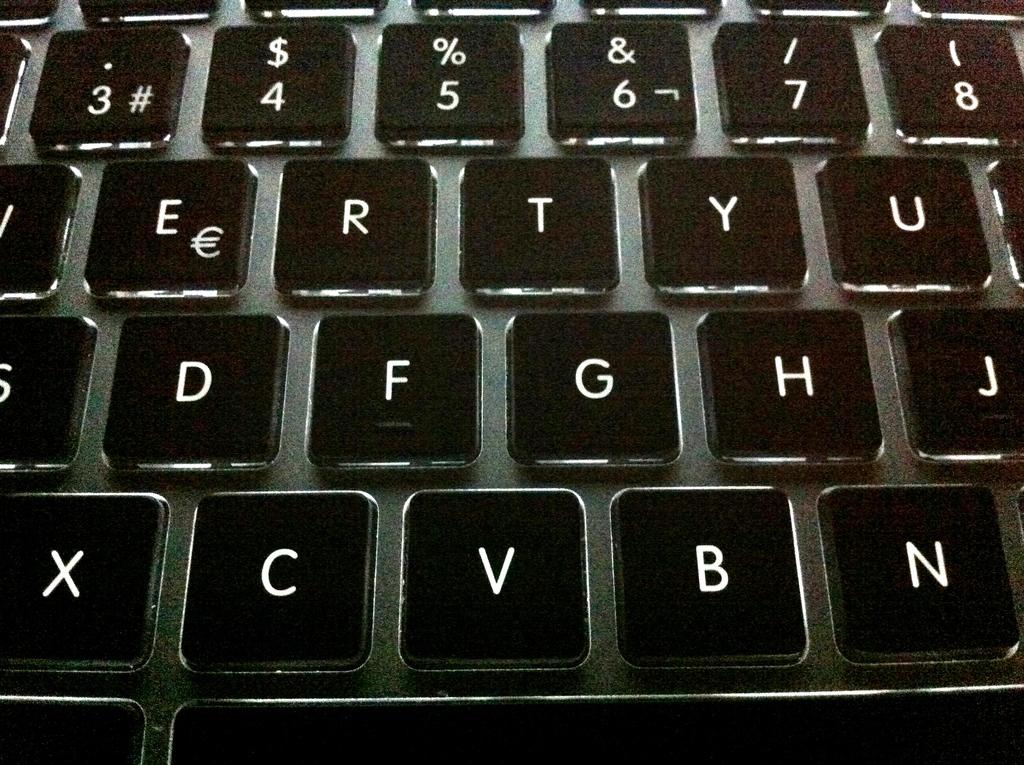What letter is to the right of "c" ?
Offer a terse response. V. What symbol is also on the number 4?
Provide a succinct answer. $. 